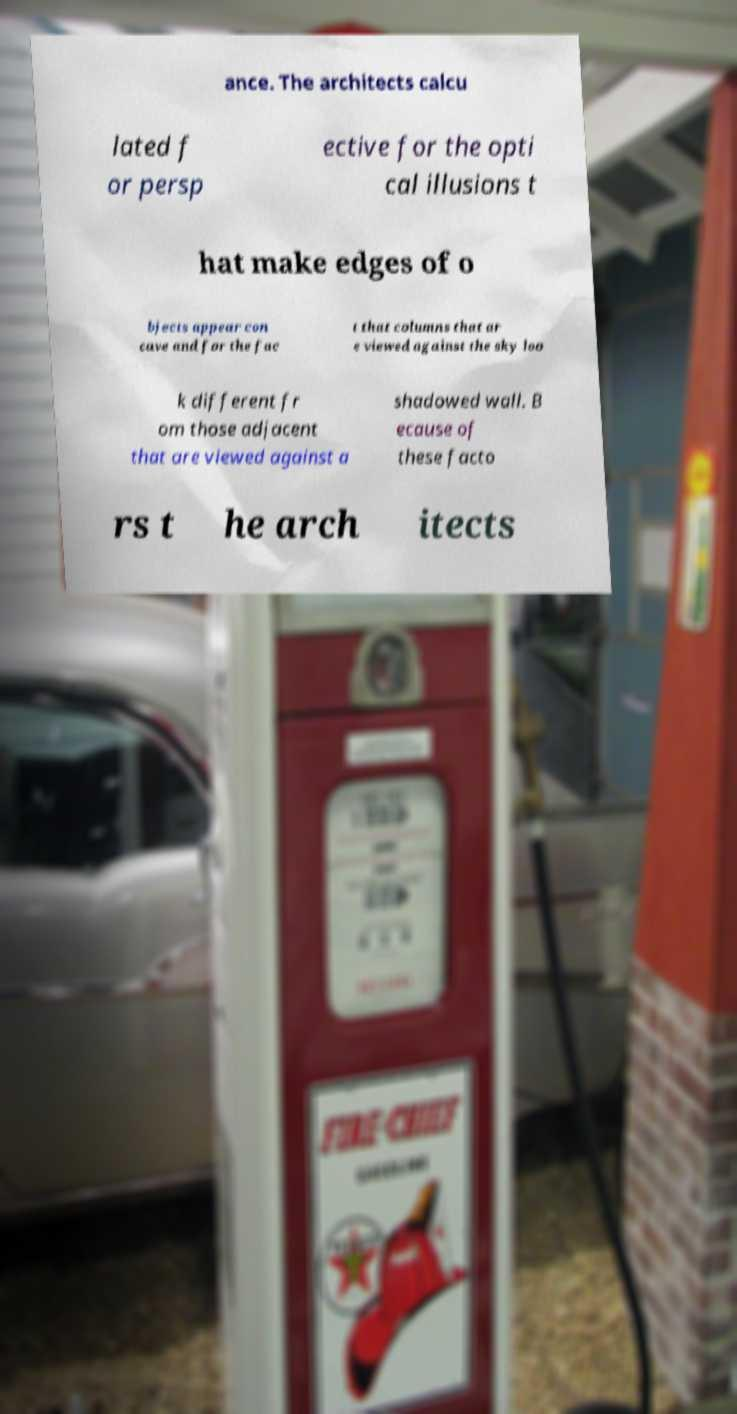Can you read and provide the text displayed in the image?This photo seems to have some interesting text. Can you extract and type it out for me? ance. The architects calcu lated f or persp ective for the opti cal illusions t hat make edges of o bjects appear con cave and for the fac t that columns that ar e viewed against the sky loo k different fr om those adjacent that are viewed against a shadowed wall. B ecause of these facto rs t he arch itects 